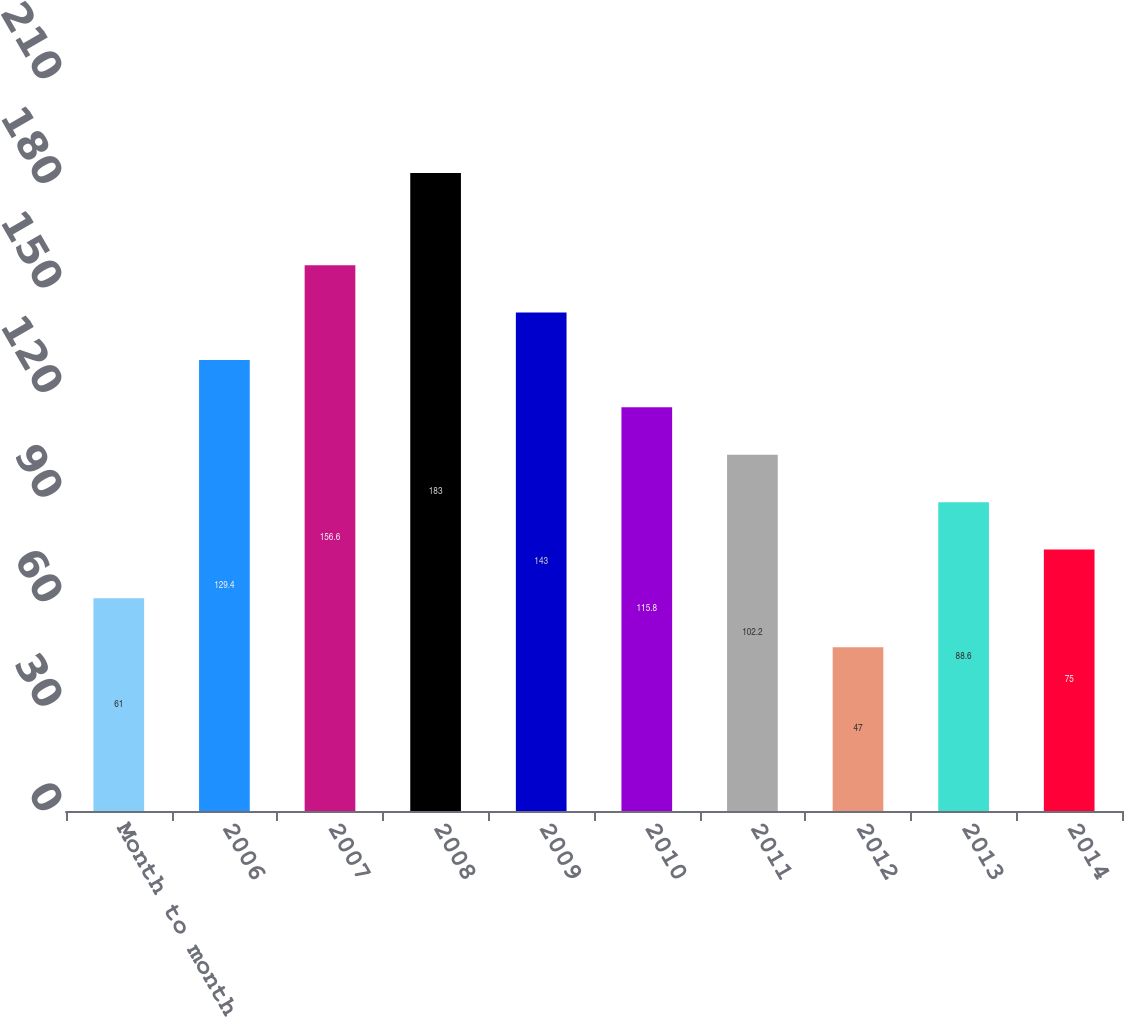Convert chart to OTSL. <chart><loc_0><loc_0><loc_500><loc_500><bar_chart><fcel>Month to month<fcel>2006<fcel>2007<fcel>2008<fcel>2009<fcel>2010<fcel>2011<fcel>2012<fcel>2013<fcel>2014<nl><fcel>61<fcel>129.4<fcel>156.6<fcel>183<fcel>143<fcel>115.8<fcel>102.2<fcel>47<fcel>88.6<fcel>75<nl></chart> 